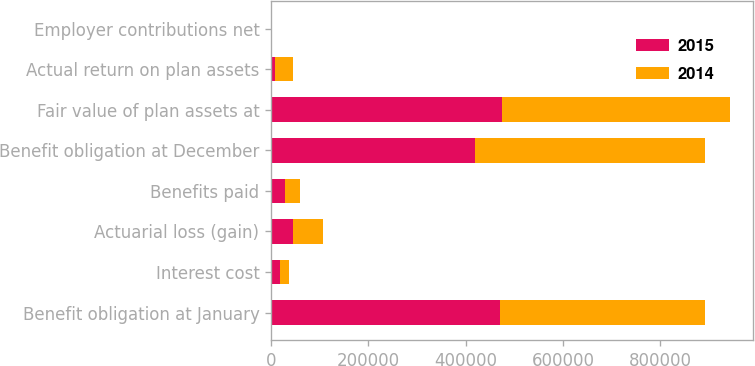<chart> <loc_0><loc_0><loc_500><loc_500><stacked_bar_chart><ecel><fcel>Benefit obligation at January<fcel>Interest cost<fcel>Actuarial loss (gain)<fcel>Benefits paid<fcel>Benefit obligation at December<fcel>Fair value of plan assets at<fcel>Actual return on plan assets<fcel>Employer contributions net<nl><fcel>2015<fcel>471259<fcel>18102<fcel>44159<fcel>29406<fcel>419626<fcel>475281<fcel>8220<fcel>970<nl><fcel>2014<fcel>420664<fcel>19073<fcel>61804<fcel>30282<fcel>471259<fcel>467912<fcel>36474<fcel>1177<nl></chart> 